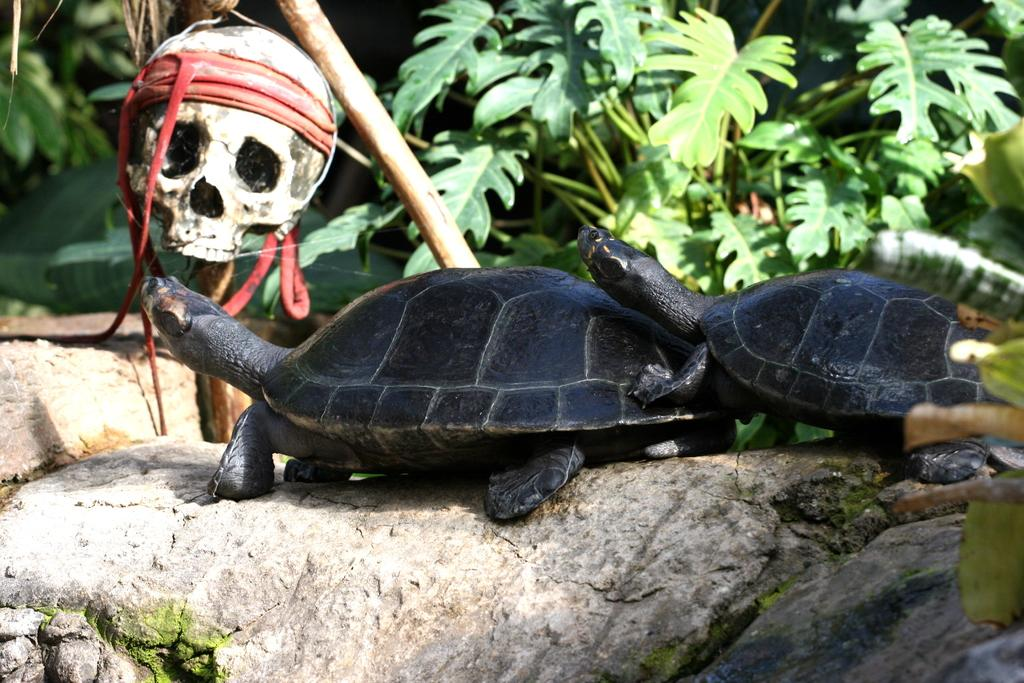How many tortoises are in the image? There are two tortoises in the image. What surface are the tortoises on? The tortoises are on a stone surface. What can be seen in the background of the image? There are plants, a wooden object, and a skull in the background of the image. What color is the tongue of the tortoise in the image? There is no visible tongue on the tortoises in the image. 